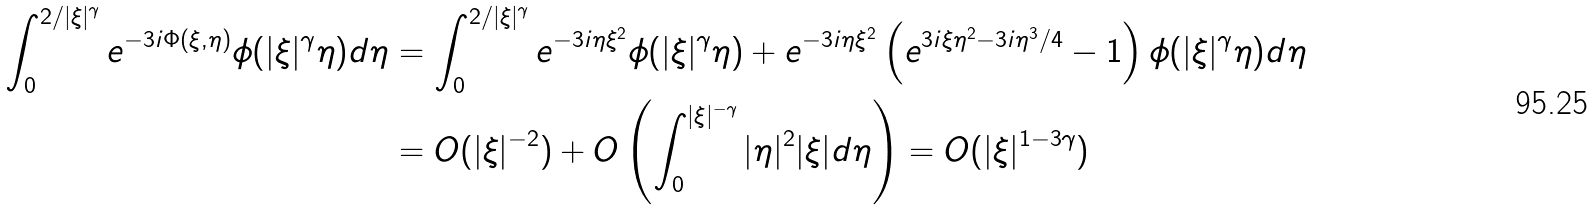Convert formula to latex. <formula><loc_0><loc_0><loc_500><loc_500>\int _ { 0 } ^ { 2 / | \xi | ^ { \gamma } } e ^ { - 3 i \Phi ( \xi , \eta ) } \phi ( | \xi | ^ { \gamma } \eta ) d \eta & = \int _ { 0 } ^ { 2 / | \xi | ^ { \gamma } } e ^ { - 3 i \eta \xi ^ { 2 } } \phi ( | \xi | ^ { \gamma } \eta ) + e ^ { - 3 i \eta \xi ^ { 2 } } \left ( e ^ { 3 i \xi \eta ^ { 2 } - 3 i \eta ^ { 3 } / 4 } - 1 \right ) \phi ( | \xi | ^ { \gamma } \eta ) d \eta \\ & = O ( | \xi | ^ { - 2 } ) + O \left ( \int _ { 0 } ^ { | \xi | ^ { - \gamma } } | \eta | ^ { 2 } | \xi | d \eta \right ) = O ( | \xi | ^ { 1 - 3 \gamma } )</formula> 